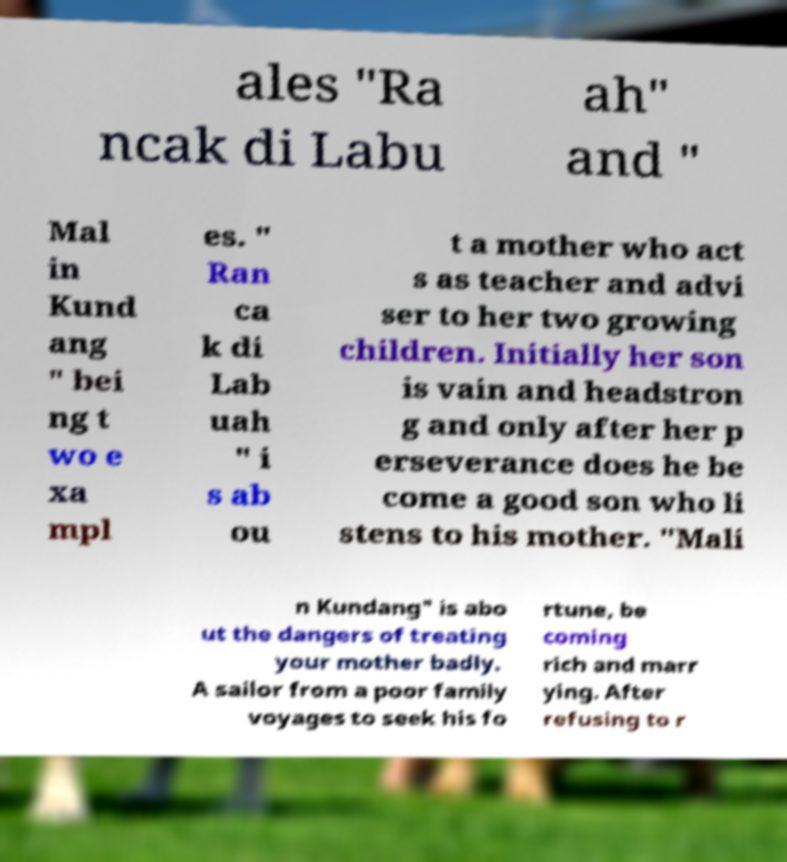I need the written content from this picture converted into text. Can you do that? ales "Ra ncak di Labu ah" and " Mal in Kund ang " bei ng t wo e xa mpl es. " Ran ca k di Lab uah " i s ab ou t a mother who act s as teacher and advi ser to her two growing children. Initially her son is vain and headstron g and only after her p erseverance does he be come a good son who li stens to his mother. "Mali n Kundang" is abo ut the dangers of treating your mother badly. A sailor from a poor family voyages to seek his fo rtune, be coming rich and marr ying. After refusing to r 